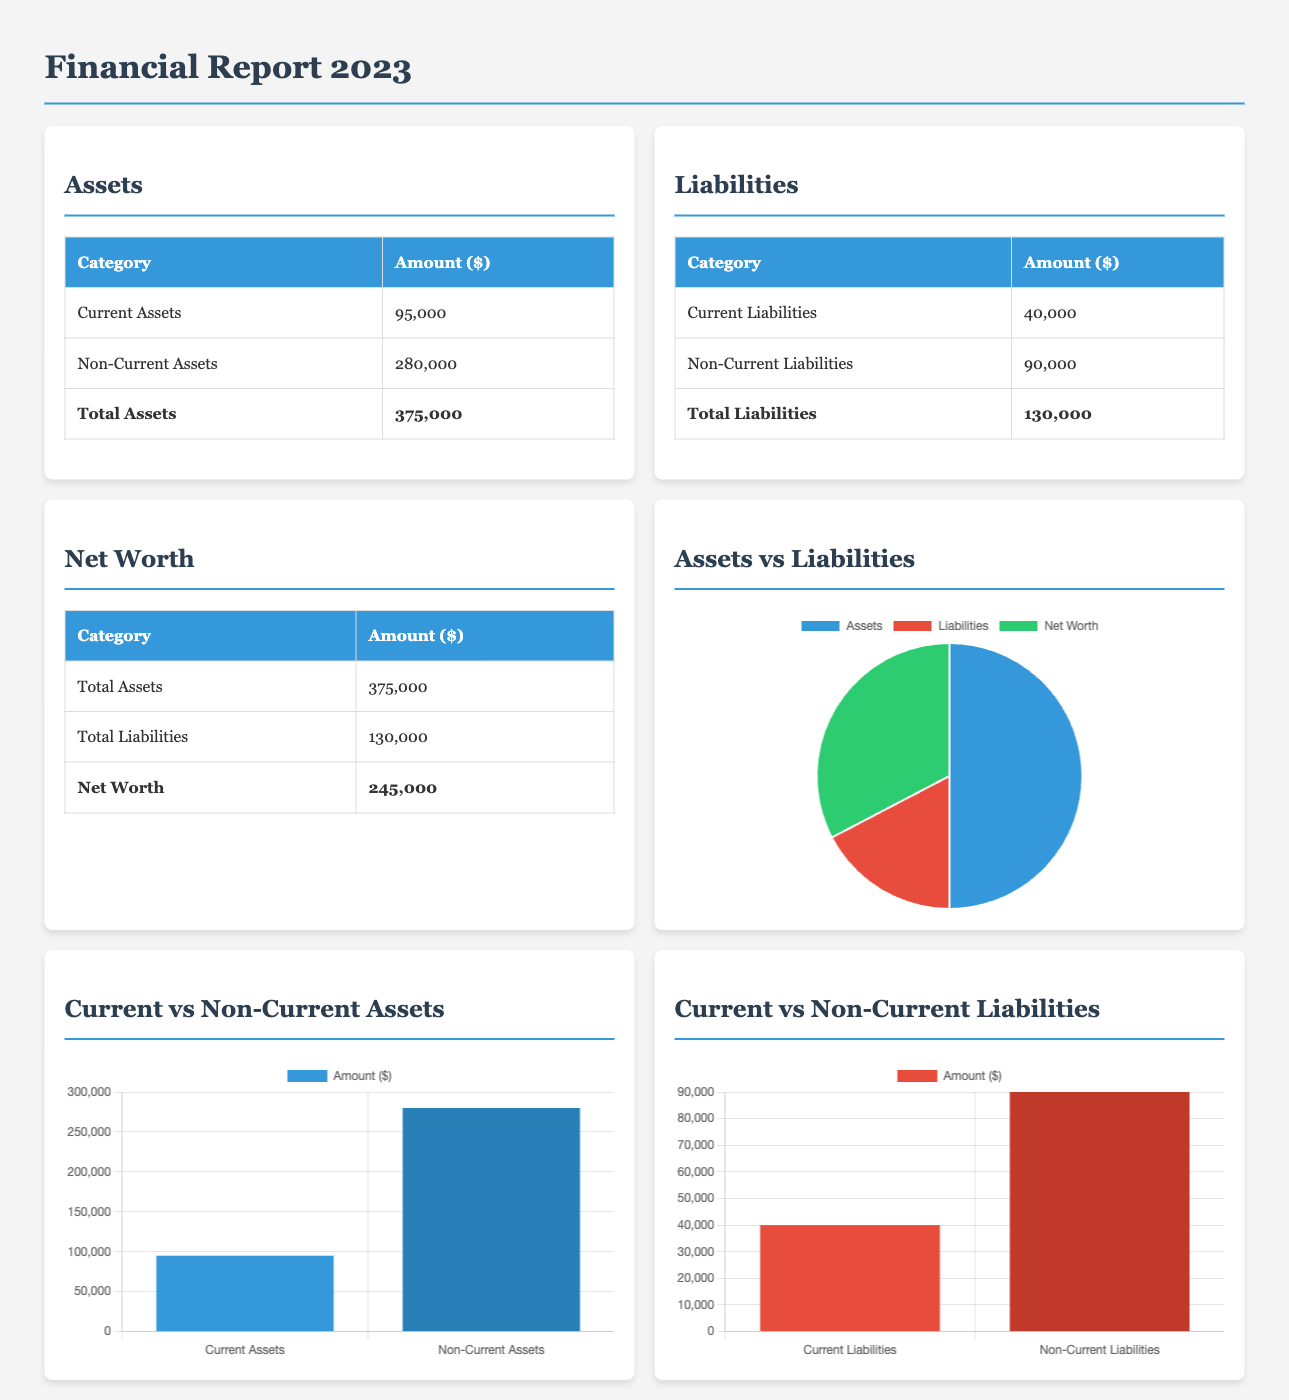What is the total assets? The total assets are given in the document as the sum of current and non-current assets, which is $95,000 + $280,000.
Answer: $375,000 What is the amount of current liabilities? The current liabilities are explicitly listed in the document as $40,000.
Answer: $40,000 What is the net worth? The net worth is calculated as total assets minus total liabilities, which is $375,000 - $130,000.
Answer: $245,000 Which category has the highest amount in assets? The non-current assets have the highest amount listed in the assets section of the document at $280,000.
Answer: Non-Current Assets What is the total amount of non-current liabilities? The total amount of non-current liabilities is provided in the document as $90,000.
Answer: $90,000 What type of chart represents Assets vs Liabilities? The chart used in the document to represent Assets vs Liabilities is a pie chart.
Answer: Pie How much more do non-current assets have compared to current assets? The difference between non-current assets ($280,000) and current assets ($95,000) is calculated as $280,000 - $95,000.
Answer: $185,000 What percentage of total liabilities is composed of current liabilities? The percentage can be calculated as (current liabilities / total liabilities) * 100, which is ($40,000 / $130,000) * 100.
Answer: 30.77% Which graphical representation shows current vs non-current liabilities? The graphical representation for current vs non-current liabilities is a bar chart.
Answer: Bar 